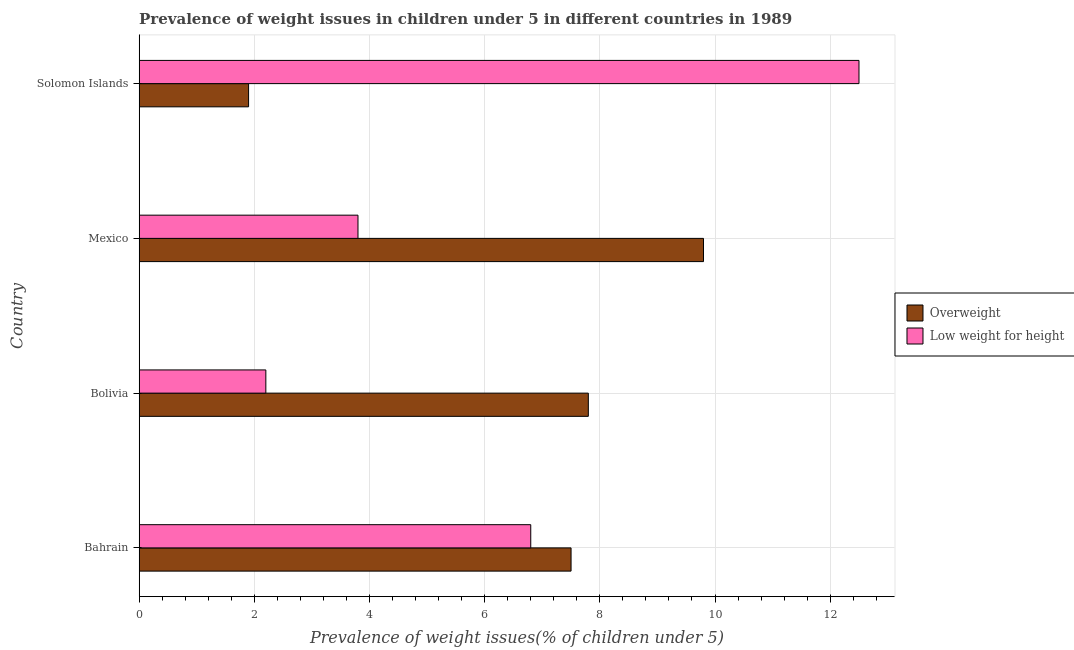How many different coloured bars are there?
Your response must be concise. 2. How many groups of bars are there?
Ensure brevity in your answer.  4. Are the number of bars on each tick of the Y-axis equal?
Your response must be concise. Yes. How many bars are there on the 1st tick from the top?
Ensure brevity in your answer.  2. How many bars are there on the 1st tick from the bottom?
Your answer should be compact. 2. What is the label of the 2nd group of bars from the top?
Give a very brief answer. Mexico. What is the percentage of overweight children in Mexico?
Make the answer very short. 9.8. Across all countries, what is the maximum percentage of underweight children?
Your answer should be compact. 12.5. Across all countries, what is the minimum percentage of underweight children?
Your answer should be very brief. 2.2. In which country was the percentage of overweight children maximum?
Your response must be concise. Mexico. In which country was the percentage of overweight children minimum?
Ensure brevity in your answer.  Solomon Islands. What is the total percentage of overweight children in the graph?
Provide a short and direct response. 27. What is the difference between the percentage of underweight children in Mexico and the percentage of overweight children in Solomon Islands?
Your answer should be very brief. 1.9. What is the average percentage of underweight children per country?
Ensure brevity in your answer.  6.33. In how many countries, is the percentage of underweight children greater than 12 %?
Provide a short and direct response. 1. What is the ratio of the percentage of overweight children in Bahrain to that in Solomon Islands?
Provide a succinct answer. 3.95. What is the difference between the highest and the second highest percentage of overweight children?
Make the answer very short. 2. What does the 1st bar from the top in Bolivia represents?
Make the answer very short. Low weight for height. What does the 2nd bar from the bottom in Bahrain represents?
Your answer should be compact. Low weight for height. How many bars are there?
Provide a succinct answer. 8. Are all the bars in the graph horizontal?
Provide a succinct answer. Yes. Are the values on the major ticks of X-axis written in scientific E-notation?
Make the answer very short. No. Does the graph contain grids?
Your response must be concise. Yes. Where does the legend appear in the graph?
Make the answer very short. Center right. How are the legend labels stacked?
Offer a very short reply. Vertical. What is the title of the graph?
Offer a terse response. Prevalence of weight issues in children under 5 in different countries in 1989. Does "Secondary school" appear as one of the legend labels in the graph?
Your response must be concise. No. What is the label or title of the X-axis?
Your answer should be compact. Prevalence of weight issues(% of children under 5). What is the Prevalence of weight issues(% of children under 5) of Overweight in Bahrain?
Provide a succinct answer. 7.5. What is the Prevalence of weight issues(% of children under 5) of Low weight for height in Bahrain?
Make the answer very short. 6.8. What is the Prevalence of weight issues(% of children under 5) in Overweight in Bolivia?
Give a very brief answer. 7.8. What is the Prevalence of weight issues(% of children under 5) of Low weight for height in Bolivia?
Provide a short and direct response. 2.2. What is the Prevalence of weight issues(% of children under 5) in Overweight in Mexico?
Your response must be concise. 9.8. What is the Prevalence of weight issues(% of children under 5) of Low weight for height in Mexico?
Your answer should be very brief. 3.8. What is the Prevalence of weight issues(% of children under 5) in Overweight in Solomon Islands?
Keep it short and to the point. 1.9. Across all countries, what is the maximum Prevalence of weight issues(% of children under 5) of Overweight?
Your response must be concise. 9.8. Across all countries, what is the minimum Prevalence of weight issues(% of children under 5) in Overweight?
Your response must be concise. 1.9. Across all countries, what is the minimum Prevalence of weight issues(% of children under 5) of Low weight for height?
Give a very brief answer. 2.2. What is the total Prevalence of weight issues(% of children under 5) in Overweight in the graph?
Your answer should be very brief. 27. What is the total Prevalence of weight issues(% of children under 5) in Low weight for height in the graph?
Make the answer very short. 25.3. What is the difference between the Prevalence of weight issues(% of children under 5) of Low weight for height in Bahrain and that in Bolivia?
Make the answer very short. 4.6. What is the difference between the Prevalence of weight issues(% of children under 5) in Low weight for height in Bahrain and that in Mexico?
Keep it short and to the point. 3. What is the difference between the Prevalence of weight issues(% of children under 5) in Low weight for height in Bahrain and that in Solomon Islands?
Provide a succinct answer. -5.7. What is the difference between the Prevalence of weight issues(% of children under 5) of Low weight for height in Bolivia and that in Mexico?
Make the answer very short. -1.6. What is the difference between the Prevalence of weight issues(% of children under 5) of Overweight in Bahrain and the Prevalence of weight issues(% of children under 5) of Low weight for height in Mexico?
Keep it short and to the point. 3.7. What is the difference between the Prevalence of weight issues(% of children under 5) of Overweight in Bolivia and the Prevalence of weight issues(% of children under 5) of Low weight for height in Mexico?
Give a very brief answer. 4. What is the difference between the Prevalence of weight issues(% of children under 5) of Overweight in Bolivia and the Prevalence of weight issues(% of children under 5) of Low weight for height in Solomon Islands?
Your answer should be very brief. -4.7. What is the difference between the Prevalence of weight issues(% of children under 5) in Overweight in Mexico and the Prevalence of weight issues(% of children under 5) in Low weight for height in Solomon Islands?
Your answer should be very brief. -2.7. What is the average Prevalence of weight issues(% of children under 5) in Overweight per country?
Keep it short and to the point. 6.75. What is the average Prevalence of weight issues(% of children under 5) of Low weight for height per country?
Your answer should be compact. 6.33. What is the ratio of the Prevalence of weight issues(% of children under 5) in Overweight in Bahrain to that in Bolivia?
Your answer should be compact. 0.96. What is the ratio of the Prevalence of weight issues(% of children under 5) of Low weight for height in Bahrain to that in Bolivia?
Keep it short and to the point. 3.09. What is the ratio of the Prevalence of weight issues(% of children under 5) in Overweight in Bahrain to that in Mexico?
Make the answer very short. 0.77. What is the ratio of the Prevalence of weight issues(% of children under 5) of Low weight for height in Bahrain to that in Mexico?
Your response must be concise. 1.79. What is the ratio of the Prevalence of weight issues(% of children under 5) of Overweight in Bahrain to that in Solomon Islands?
Provide a succinct answer. 3.95. What is the ratio of the Prevalence of weight issues(% of children under 5) of Low weight for height in Bahrain to that in Solomon Islands?
Provide a succinct answer. 0.54. What is the ratio of the Prevalence of weight issues(% of children under 5) in Overweight in Bolivia to that in Mexico?
Your response must be concise. 0.8. What is the ratio of the Prevalence of weight issues(% of children under 5) of Low weight for height in Bolivia to that in Mexico?
Your answer should be very brief. 0.58. What is the ratio of the Prevalence of weight issues(% of children under 5) of Overweight in Bolivia to that in Solomon Islands?
Your response must be concise. 4.11. What is the ratio of the Prevalence of weight issues(% of children under 5) in Low weight for height in Bolivia to that in Solomon Islands?
Keep it short and to the point. 0.18. What is the ratio of the Prevalence of weight issues(% of children under 5) of Overweight in Mexico to that in Solomon Islands?
Provide a succinct answer. 5.16. What is the ratio of the Prevalence of weight issues(% of children under 5) of Low weight for height in Mexico to that in Solomon Islands?
Give a very brief answer. 0.3. What is the difference between the highest and the second highest Prevalence of weight issues(% of children under 5) in Overweight?
Your answer should be compact. 2. What is the difference between the highest and the second highest Prevalence of weight issues(% of children under 5) of Low weight for height?
Your answer should be very brief. 5.7. What is the difference between the highest and the lowest Prevalence of weight issues(% of children under 5) in Overweight?
Give a very brief answer. 7.9. 